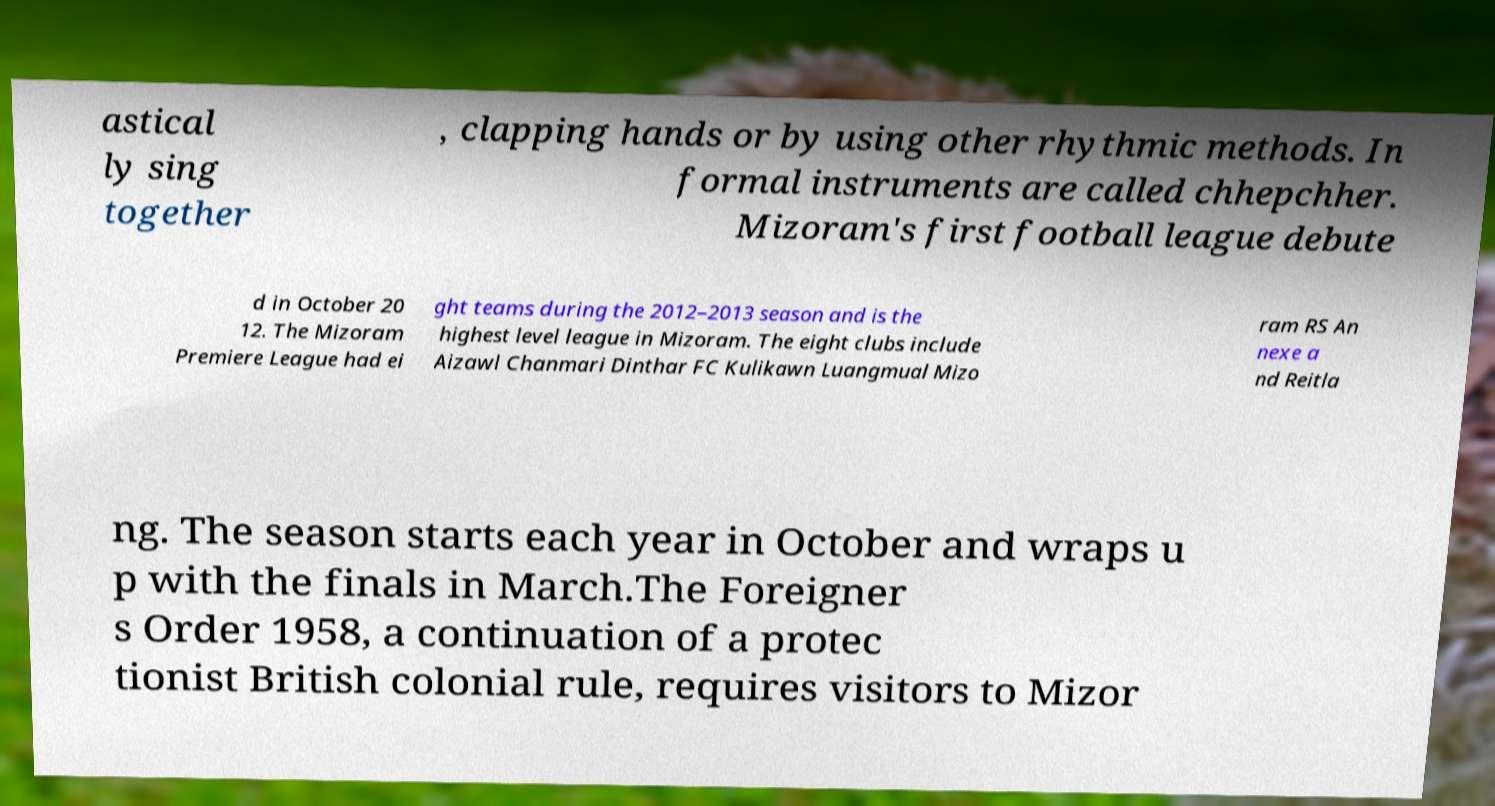I need the written content from this picture converted into text. Can you do that? astical ly sing together , clapping hands or by using other rhythmic methods. In formal instruments are called chhepchher. Mizoram's first football league debute d in October 20 12. The Mizoram Premiere League had ei ght teams during the 2012–2013 season and is the highest level league in Mizoram. The eight clubs include Aizawl Chanmari Dinthar FC Kulikawn Luangmual Mizo ram RS An nexe a nd Reitla ng. The season starts each year in October and wraps u p with the finals in March.The Foreigner s Order 1958, a continuation of a protec tionist British colonial rule, requires visitors to Mizor 